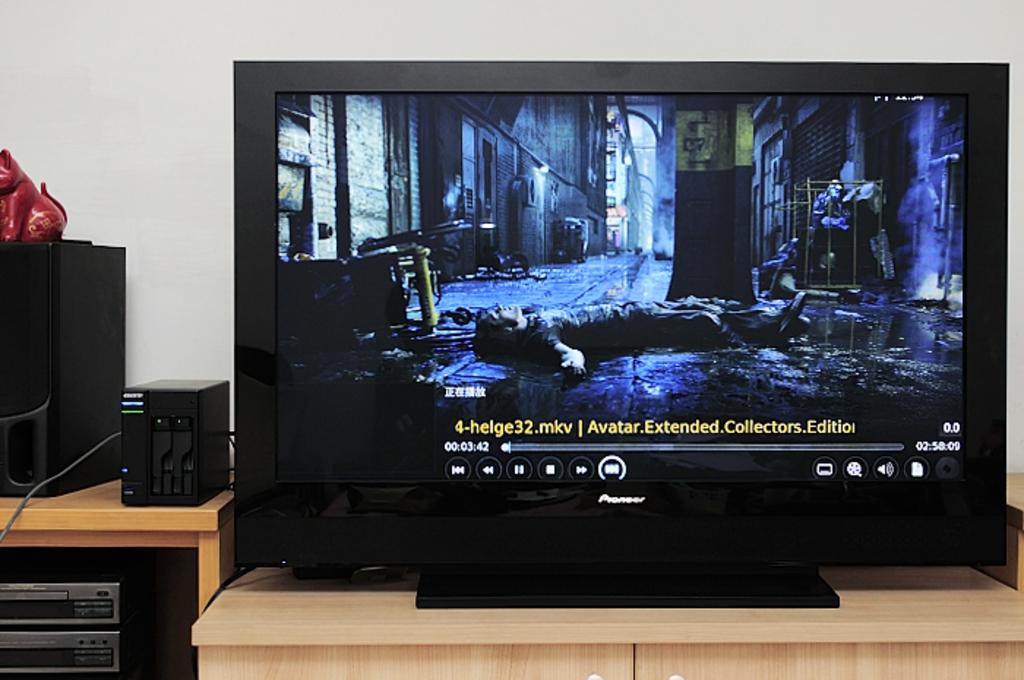<image>
Share a concise interpretation of the image provided. A monitor shows a paused screen of a body lying in a dark street and has the words Avatar Extended Collectors Edition at the bottom. 